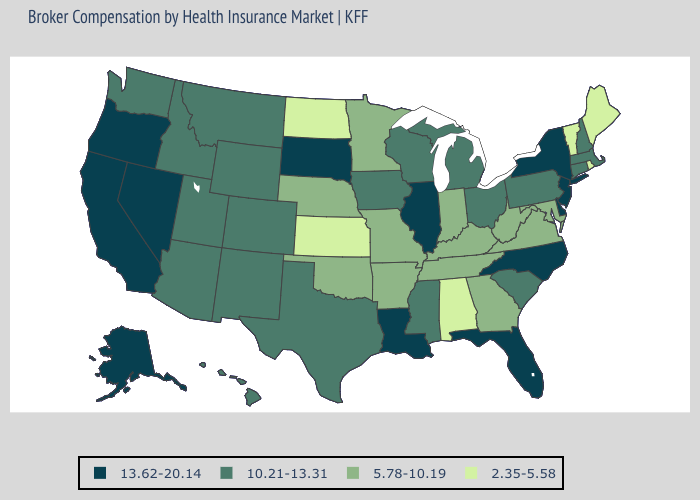What is the highest value in states that border Arkansas?
Be succinct. 13.62-20.14. Which states have the highest value in the USA?
Quick response, please. Alaska, California, Delaware, Florida, Illinois, Louisiana, Nevada, New Jersey, New York, North Carolina, Oregon, South Dakota. Name the states that have a value in the range 10.21-13.31?
Quick response, please. Arizona, Colorado, Connecticut, Hawaii, Idaho, Iowa, Massachusetts, Michigan, Mississippi, Montana, New Hampshire, New Mexico, Ohio, Pennsylvania, South Carolina, Texas, Utah, Washington, Wisconsin, Wyoming. Does Rhode Island have the lowest value in the USA?
Answer briefly. Yes. Among the states that border Florida , which have the highest value?
Short answer required. Georgia. Which states have the lowest value in the South?
Be succinct. Alabama. How many symbols are there in the legend?
Concise answer only. 4. Name the states that have a value in the range 10.21-13.31?
Keep it brief. Arizona, Colorado, Connecticut, Hawaii, Idaho, Iowa, Massachusetts, Michigan, Mississippi, Montana, New Hampshire, New Mexico, Ohio, Pennsylvania, South Carolina, Texas, Utah, Washington, Wisconsin, Wyoming. What is the value of Florida?
Keep it brief. 13.62-20.14. Does Pennsylvania have a higher value than Utah?
Quick response, please. No. What is the highest value in states that border Nebraska?
Write a very short answer. 13.62-20.14. Does the first symbol in the legend represent the smallest category?
Keep it brief. No. What is the value of Colorado?
Concise answer only. 10.21-13.31. 